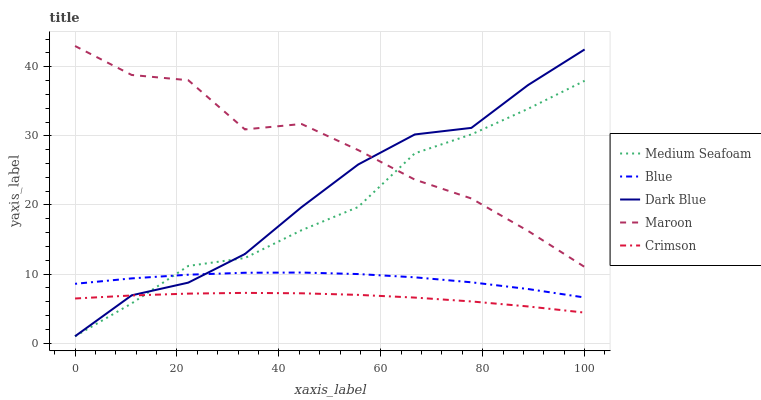Does Crimson have the minimum area under the curve?
Answer yes or no. Yes. Does Maroon have the maximum area under the curve?
Answer yes or no. Yes. Does Dark Blue have the minimum area under the curve?
Answer yes or no. No. Does Dark Blue have the maximum area under the curve?
Answer yes or no. No. Is Crimson the smoothest?
Answer yes or no. Yes. Is Maroon the roughest?
Answer yes or no. Yes. Is Dark Blue the smoothest?
Answer yes or no. No. Is Dark Blue the roughest?
Answer yes or no. No. Does Crimson have the lowest value?
Answer yes or no. No. Does Maroon have the highest value?
Answer yes or no. Yes. Does Dark Blue have the highest value?
Answer yes or no. No. Is Crimson less than Maroon?
Answer yes or no. Yes. Is Maroon greater than Blue?
Answer yes or no. Yes. Does Maroon intersect Medium Seafoam?
Answer yes or no. Yes. Is Maroon less than Medium Seafoam?
Answer yes or no. No. Is Maroon greater than Medium Seafoam?
Answer yes or no. No. Does Crimson intersect Maroon?
Answer yes or no. No. 